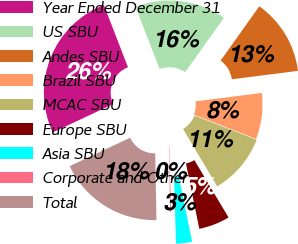Convert chart. <chart><loc_0><loc_0><loc_500><loc_500><pie_chart><fcel>Year Ended December 31<fcel>US SBU<fcel>Andes SBU<fcel>Brazil SBU<fcel>MCAC SBU<fcel>Europe SBU<fcel>Asia SBU<fcel>Corporate and Other<fcel>Total<nl><fcel>26.1%<fcel>15.72%<fcel>13.13%<fcel>7.94%<fcel>10.53%<fcel>5.34%<fcel>2.75%<fcel>0.16%<fcel>18.32%<nl></chart> 